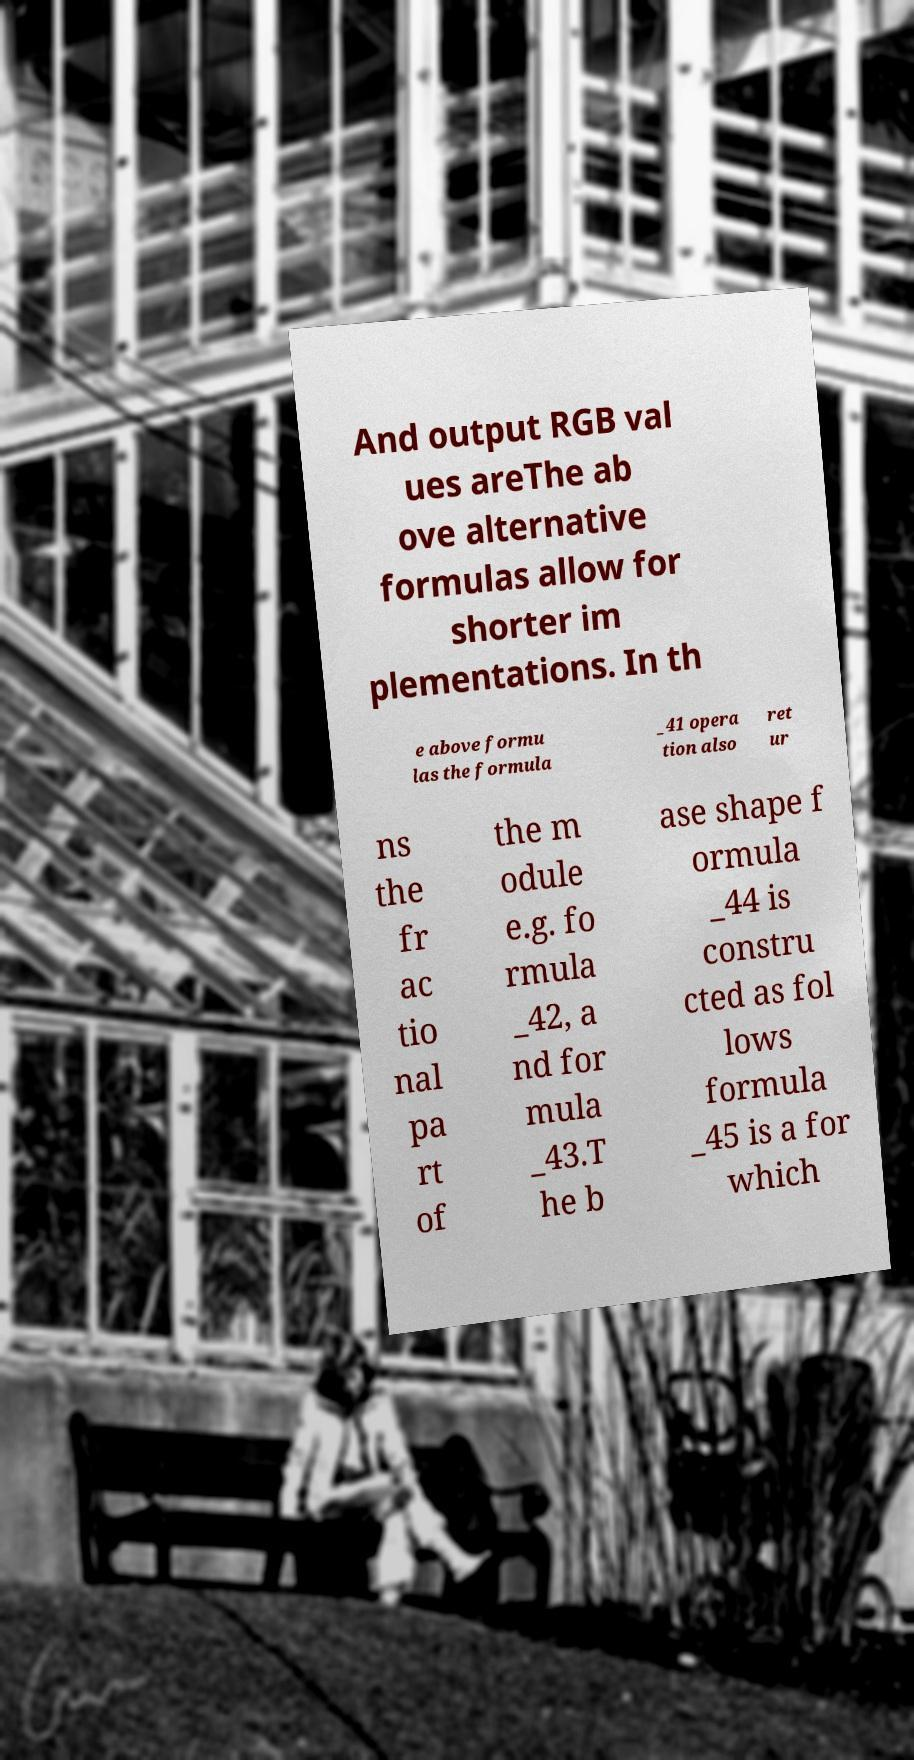What messages or text are displayed in this image? I need them in a readable, typed format. And output RGB val ues areThe ab ove alternative formulas allow for shorter im plementations. In th e above formu las the formula _41 opera tion also ret ur ns the fr ac tio nal pa rt of the m odule e.g. fo rmula _42, a nd for mula _43.T he b ase shape f ormula _44 is constru cted as fol lows formula _45 is a for which 